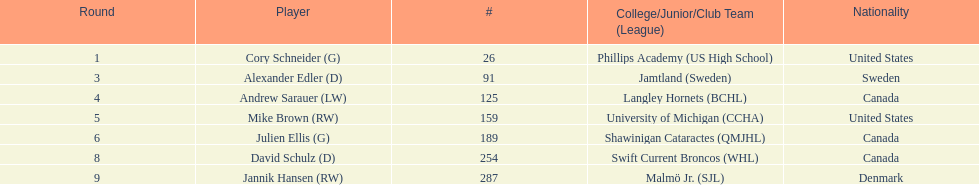What number of players have canada listed as their nationality? 3. 